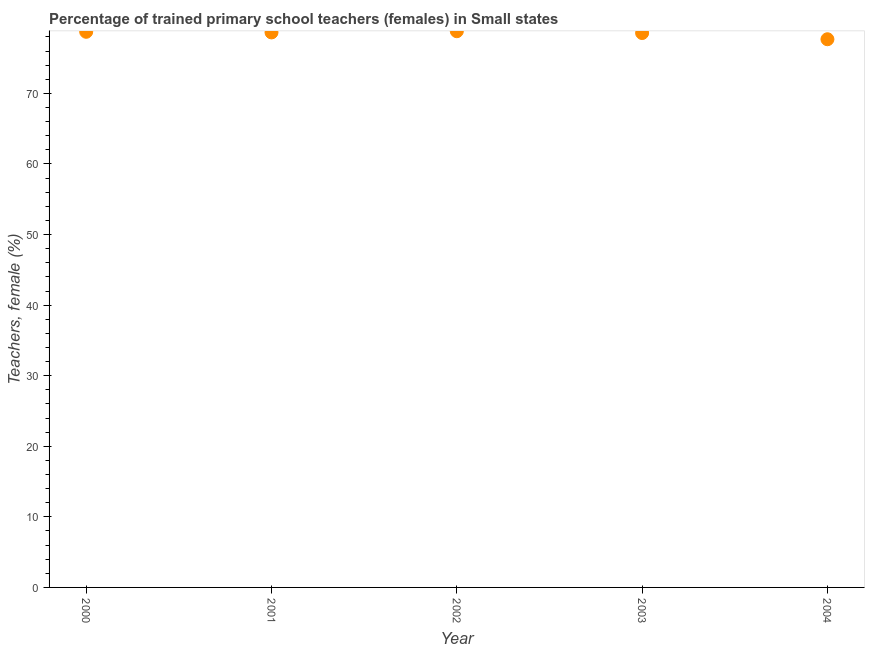What is the percentage of trained female teachers in 2002?
Provide a short and direct response. 78.81. Across all years, what is the maximum percentage of trained female teachers?
Make the answer very short. 78.81. Across all years, what is the minimum percentage of trained female teachers?
Your answer should be compact. 77.68. In which year was the percentage of trained female teachers maximum?
Keep it short and to the point. 2002. What is the sum of the percentage of trained female teachers?
Offer a very short reply. 392.42. What is the difference between the percentage of trained female teachers in 2001 and 2004?
Provide a short and direct response. 0.97. What is the average percentage of trained female teachers per year?
Offer a very short reply. 78.48. What is the median percentage of trained female teachers?
Keep it short and to the point. 78.64. Do a majority of the years between 2003 and 2004 (inclusive) have percentage of trained female teachers greater than 58 %?
Your answer should be very brief. Yes. What is the ratio of the percentage of trained female teachers in 2001 to that in 2003?
Make the answer very short. 1. Is the percentage of trained female teachers in 2001 less than that in 2003?
Your response must be concise. No. What is the difference between the highest and the second highest percentage of trained female teachers?
Ensure brevity in your answer.  0.08. What is the difference between the highest and the lowest percentage of trained female teachers?
Your answer should be compact. 1.14. Does the percentage of trained female teachers monotonically increase over the years?
Ensure brevity in your answer.  No. What is the difference between two consecutive major ticks on the Y-axis?
Ensure brevity in your answer.  10. Does the graph contain grids?
Offer a very short reply. No. What is the title of the graph?
Provide a succinct answer. Percentage of trained primary school teachers (females) in Small states. What is the label or title of the Y-axis?
Provide a short and direct response. Teachers, female (%). What is the Teachers, female (%) in 2000?
Offer a very short reply. 78.73. What is the Teachers, female (%) in 2001?
Keep it short and to the point. 78.64. What is the Teachers, female (%) in 2002?
Provide a short and direct response. 78.81. What is the Teachers, female (%) in 2003?
Ensure brevity in your answer.  78.56. What is the Teachers, female (%) in 2004?
Offer a very short reply. 77.68. What is the difference between the Teachers, female (%) in 2000 and 2001?
Your answer should be compact. 0.09. What is the difference between the Teachers, female (%) in 2000 and 2002?
Offer a very short reply. -0.08. What is the difference between the Teachers, female (%) in 2000 and 2003?
Offer a terse response. 0.17. What is the difference between the Teachers, female (%) in 2000 and 2004?
Give a very brief answer. 1.05. What is the difference between the Teachers, female (%) in 2001 and 2002?
Make the answer very short. -0.17. What is the difference between the Teachers, female (%) in 2001 and 2003?
Your answer should be compact. 0.09. What is the difference between the Teachers, female (%) in 2001 and 2004?
Your response must be concise. 0.97. What is the difference between the Teachers, female (%) in 2002 and 2003?
Keep it short and to the point. 0.26. What is the difference between the Teachers, female (%) in 2002 and 2004?
Ensure brevity in your answer.  1.14. What is the difference between the Teachers, female (%) in 2003 and 2004?
Provide a short and direct response. 0.88. What is the ratio of the Teachers, female (%) in 2000 to that in 2001?
Your answer should be very brief. 1. What is the ratio of the Teachers, female (%) in 2000 to that in 2002?
Your response must be concise. 1. What is the ratio of the Teachers, female (%) in 2000 to that in 2004?
Give a very brief answer. 1.01. What is the ratio of the Teachers, female (%) in 2001 to that in 2002?
Offer a terse response. 1. What is the ratio of the Teachers, female (%) in 2001 to that in 2003?
Your response must be concise. 1. What is the ratio of the Teachers, female (%) in 2001 to that in 2004?
Offer a very short reply. 1.01. What is the ratio of the Teachers, female (%) in 2002 to that in 2003?
Offer a very short reply. 1. What is the ratio of the Teachers, female (%) in 2002 to that in 2004?
Provide a succinct answer. 1.01. 